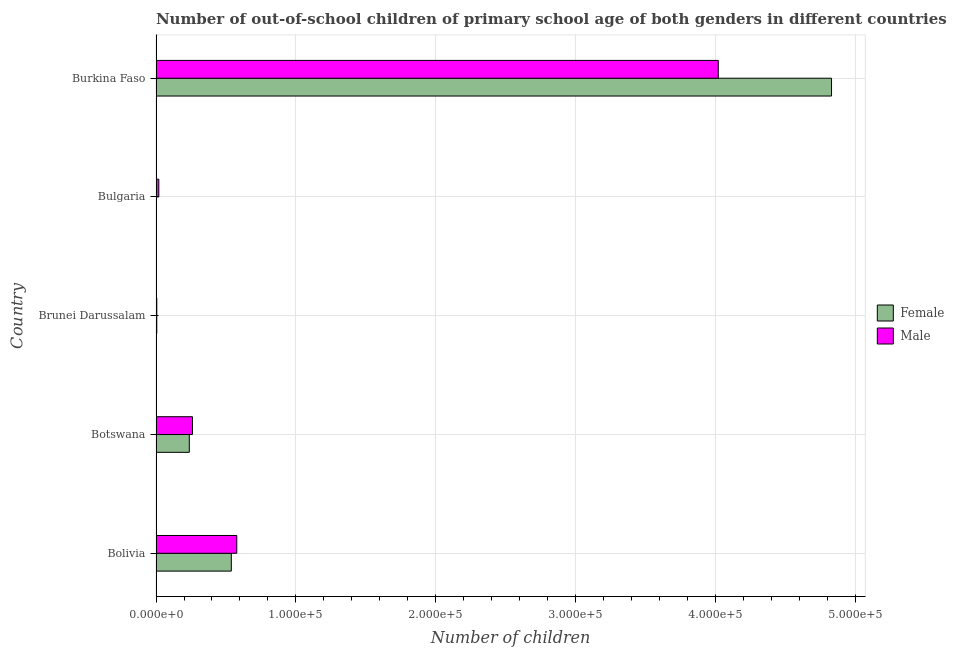How many different coloured bars are there?
Give a very brief answer. 2. How many groups of bars are there?
Your response must be concise. 5. Are the number of bars per tick equal to the number of legend labels?
Your response must be concise. Yes. Are the number of bars on each tick of the Y-axis equal?
Ensure brevity in your answer.  Yes. What is the label of the 3rd group of bars from the top?
Give a very brief answer. Brunei Darussalam. In how many cases, is the number of bars for a given country not equal to the number of legend labels?
Provide a succinct answer. 0. What is the number of female out-of-school students in Botswana?
Offer a terse response. 2.38e+04. Across all countries, what is the maximum number of female out-of-school students?
Your answer should be very brief. 4.83e+05. Across all countries, what is the minimum number of female out-of-school students?
Provide a short and direct response. 334. In which country was the number of female out-of-school students maximum?
Offer a very short reply. Burkina Faso. What is the total number of female out-of-school students in the graph?
Make the answer very short. 5.61e+05. What is the difference between the number of male out-of-school students in Botswana and that in Burkina Faso?
Keep it short and to the point. -3.76e+05. What is the difference between the number of male out-of-school students in Botswana and the number of female out-of-school students in Brunei Darussalam?
Ensure brevity in your answer.  2.55e+04. What is the average number of male out-of-school students per country?
Ensure brevity in your answer.  9.76e+04. What is the difference between the number of female out-of-school students and number of male out-of-school students in Brunei Darussalam?
Provide a short and direct response. -14. In how many countries, is the number of female out-of-school students greater than 440000 ?
Offer a very short reply. 1. What is the ratio of the number of female out-of-school students in Brunei Darussalam to that in Bulgaria?
Your answer should be very brief. 1.61. Is the number of male out-of-school students in Botswana less than that in Bulgaria?
Keep it short and to the point. No. Is the difference between the number of male out-of-school students in Bulgaria and Burkina Faso greater than the difference between the number of female out-of-school students in Bulgaria and Burkina Faso?
Offer a very short reply. Yes. What is the difference between the highest and the second highest number of male out-of-school students?
Offer a terse response. 3.44e+05. What is the difference between the highest and the lowest number of male out-of-school students?
Give a very brief answer. 4.01e+05. What does the 2nd bar from the bottom in Brunei Darussalam represents?
Your answer should be very brief. Male. What is the difference between two consecutive major ticks on the X-axis?
Make the answer very short. 1.00e+05. Are the values on the major ticks of X-axis written in scientific E-notation?
Make the answer very short. Yes. Does the graph contain grids?
Give a very brief answer. Yes. How are the legend labels stacked?
Offer a terse response. Vertical. What is the title of the graph?
Your answer should be very brief. Number of out-of-school children of primary school age of both genders in different countries. What is the label or title of the X-axis?
Ensure brevity in your answer.  Number of children. What is the Number of children in Female in Bolivia?
Offer a terse response. 5.38e+04. What is the Number of children in Male in Bolivia?
Offer a very short reply. 5.77e+04. What is the Number of children in Female in Botswana?
Ensure brevity in your answer.  2.38e+04. What is the Number of children in Male in Botswana?
Keep it short and to the point. 2.61e+04. What is the Number of children in Female in Brunei Darussalam?
Your response must be concise. 539. What is the Number of children in Male in Brunei Darussalam?
Offer a very short reply. 553. What is the Number of children in Female in Bulgaria?
Your response must be concise. 334. What is the Number of children in Male in Bulgaria?
Your answer should be very brief. 1993. What is the Number of children in Female in Burkina Faso?
Your answer should be compact. 4.83e+05. What is the Number of children of Male in Burkina Faso?
Ensure brevity in your answer.  4.02e+05. Across all countries, what is the maximum Number of children of Female?
Offer a terse response. 4.83e+05. Across all countries, what is the maximum Number of children of Male?
Offer a terse response. 4.02e+05. Across all countries, what is the minimum Number of children in Female?
Offer a very short reply. 334. Across all countries, what is the minimum Number of children of Male?
Provide a short and direct response. 553. What is the total Number of children of Female in the graph?
Your answer should be compact. 5.61e+05. What is the total Number of children in Male in the graph?
Offer a very short reply. 4.88e+05. What is the difference between the Number of children in Female in Bolivia and that in Botswana?
Your answer should be very brief. 3.00e+04. What is the difference between the Number of children of Male in Bolivia and that in Botswana?
Give a very brief answer. 3.17e+04. What is the difference between the Number of children of Female in Bolivia and that in Brunei Darussalam?
Offer a very short reply. 5.33e+04. What is the difference between the Number of children in Male in Bolivia and that in Brunei Darussalam?
Ensure brevity in your answer.  5.72e+04. What is the difference between the Number of children in Female in Bolivia and that in Bulgaria?
Give a very brief answer. 5.35e+04. What is the difference between the Number of children of Male in Bolivia and that in Bulgaria?
Offer a very short reply. 5.57e+04. What is the difference between the Number of children in Female in Bolivia and that in Burkina Faso?
Offer a very short reply. -4.29e+05. What is the difference between the Number of children of Male in Bolivia and that in Burkina Faso?
Your response must be concise. -3.44e+05. What is the difference between the Number of children in Female in Botswana and that in Brunei Darussalam?
Your answer should be compact. 2.32e+04. What is the difference between the Number of children in Male in Botswana and that in Brunei Darussalam?
Give a very brief answer. 2.55e+04. What is the difference between the Number of children in Female in Botswana and that in Bulgaria?
Your answer should be very brief. 2.34e+04. What is the difference between the Number of children of Male in Botswana and that in Bulgaria?
Your response must be concise. 2.41e+04. What is the difference between the Number of children of Female in Botswana and that in Burkina Faso?
Your answer should be very brief. -4.59e+05. What is the difference between the Number of children of Male in Botswana and that in Burkina Faso?
Provide a short and direct response. -3.76e+05. What is the difference between the Number of children of Female in Brunei Darussalam and that in Bulgaria?
Your answer should be compact. 205. What is the difference between the Number of children in Male in Brunei Darussalam and that in Bulgaria?
Your response must be concise. -1440. What is the difference between the Number of children in Female in Brunei Darussalam and that in Burkina Faso?
Offer a terse response. -4.82e+05. What is the difference between the Number of children of Male in Brunei Darussalam and that in Burkina Faso?
Give a very brief answer. -4.01e+05. What is the difference between the Number of children in Female in Bulgaria and that in Burkina Faso?
Provide a succinct answer. -4.82e+05. What is the difference between the Number of children in Male in Bulgaria and that in Burkina Faso?
Your response must be concise. -4.00e+05. What is the difference between the Number of children in Female in Bolivia and the Number of children in Male in Botswana?
Your answer should be very brief. 2.77e+04. What is the difference between the Number of children of Female in Bolivia and the Number of children of Male in Brunei Darussalam?
Provide a succinct answer. 5.33e+04. What is the difference between the Number of children in Female in Bolivia and the Number of children in Male in Bulgaria?
Offer a very short reply. 5.18e+04. What is the difference between the Number of children of Female in Bolivia and the Number of children of Male in Burkina Faso?
Your answer should be compact. -3.48e+05. What is the difference between the Number of children of Female in Botswana and the Number of children of Male in Brunei Darussalam?
Provide a succinct answer. 2.32e+04. What is the difference between the Number of children in Female in Botswana and the Number of children in Male in Bulgaria?
Provide a succinct answer. 2.18e+04. What is the difference between the Number of children of Female in Botswana and the Number of children of Male in Burkina Faso?
Make the answer very short. -3.78e+05. What is the difference between the Number of children in Female in Brunei Darussalam and the Number of children in Male in Bulgaria?
Ensure brevity in your answer.  -1454. What is the difference between the Number of children of Female in Brunei Darussalam and the Number of children of Male in Burkina Faso?
Ensure brevity in your answer.  -4.01e+05. What is the difference between the Number of children of Female in Bulgaria and the Number of children of Male in Burkina Faso?
Your response must be concise. -4.02e+05. What is the average Number of children of Female per country?
Make the answer very short. 1.12e+05. What is the average Number of children of Male per country?
Make the answer very short. 9.76e+04. What is the difference between the Number of children of Female and Number of children of Male in Bolivia?
Offer a very short reply. -3910. What is the difference between the Number of children of Female and Number of children of Male in Botswana?
Make the answer very short. -2287. What is the difference between the Number of children in Female and Number of children in Male in Bulgaria?
Offer a very short reply. -1659. What is the difference between the Number of children of Female and Number of children of Male in Burkina Faso?
Make the answer very short. 8.09e+04. What is the ratio of the Number of children in Female in Bolivia to that in Botswana?
Offer a very short reply. 2.26. What is the ratio of the Number of children in Male in Bolivia to that in Botswana?
Give a very brief answer. 2.21. What is the ratio of the Number of children in Female in Bolivia to that in Brunei Darussalam?
Your answer should be very brief. 99.83. What is the ratio of the Number of children in Male in Bolivia to that in Brunei Darussalam?
Ensure brevity in your answer.  104.37. What is the ratio of the Number of children in Female in Bolivia to that in Bulgaria?
Make the answer very short. 161.1. What is the ratio of the Number of children of Male in Bolivia to that in Bulgaria?
Your response must be concise. 28.96. What is the ratio of the Number of children in Female in Bolivia to that in Burkina Faso?
Your answer should be compact. 0.11. What is the ratio of the Number of children of Male in Bolivia to that in Burkina Faso?
Ensure brevity in your answer.  0.14. What is the ratio of the Number of children of Female in Botswana to that in Brunei Darussalam?
Provide a succinct answer. 44.11. What is the ratio of the Number of children of Male in Botswana to that in Brunei Darussalam?
Provide a short and direct response. 47.13. What is the ratio of the Number of children of Female in Botswana to that in Bulgaria?
Provide a short and direct response. 71.19. What is the ratio of the Number of children of Male in Botswana to that in Bulgaria?
Provide a succinct answer. 13.08. What is the ratio of the Number of children in Female in Botswana to that in Burkina Faso?
Your answer should be compact. 0.05. What is the ratio of the Number of children of Male in Botswana to that in Burkina Faso?
Offer a terse response. 0.06. What is the ratio of the Number of children in Female in Brunei Darussalam to that in Bulgaria?
Your response must be concise. 1.61. What is the ratio of the Number of children in Male in Brunei Darussalam to that in Bulgaria?
Your response must be concise. 0.28. What is the ratio of the Number of children of Female in Brunei Darussalam to that in Burkina Faso?
Provide a short and direct response. 0. What is the ratio of the Number of children of Male in Brunei Darussalam to that in Burkina Faso?
Provide a short and direct response. 0. What is the ratio of the Number of children of Female in Bulgaria to that in Burkina Faso?
Ensure brevity in your answer.  0. What is the ratio of the Number of children of Male in Bulgaria to that in Burkina Faso?
Provide a short and direct response. 0.01. What is the difference between the highest and the second highest Number of children in Female?
Make the answer very short. 4.29e+05. What is the difference between the highest and the second highest Number of children of Male?
Your response must be concise. 3.44e+05. What is the difference between the highest and the lowest Number of children in Female?
Your answer should be compact. 4.82e+05. What is the difference between the highest and the lowest Number of children in Male?
Your response must be concise. 4.01e+05. 